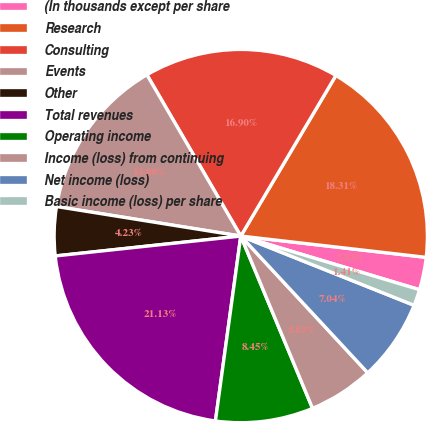Convert chart. <chart><loc_0><loc_0><loc_500><loc_500><pie_chart><fcel>(In thousands except per share<fcel>Research<fcel>Consulting<fcel>Events<fcel>Other<fcel>Total revenues<fcel>Operating income<fcel>Income (loss) from continuing<fcel>Net income (loss)<fcel>Basic income (loss) per share<nl><fcel>2.82%<fcel>18.31%<fcel>16.9%<fcel>14.08%<fcel>4.23%<fcel>21.13%<fcel>8.45%<fcel>5.63%<fcel>7.04%<fcel>1.41%<nl></chart> 